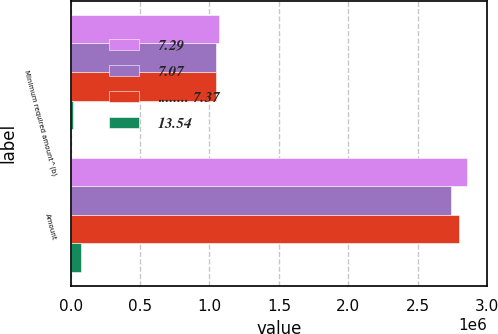<chart> <loc_0><loc_0><loc_500><loc_500><stacked_bar_chart><ecel><fcel>Minimum required amount^(b)<fcel>Amount<nl><fcel>7.29<fcel>1.06588e+06<fcel>2.85769e+06<nl><fcel>7.07<fcel>1.04718e+06<fcel>2.73998e+06<nl><fcel>........ 7.37<fcel>1.04628e+06<fcel>2.79483e+06<nl><fcel>13.54<fcel>20020<fcel>72475<nl></chart> 